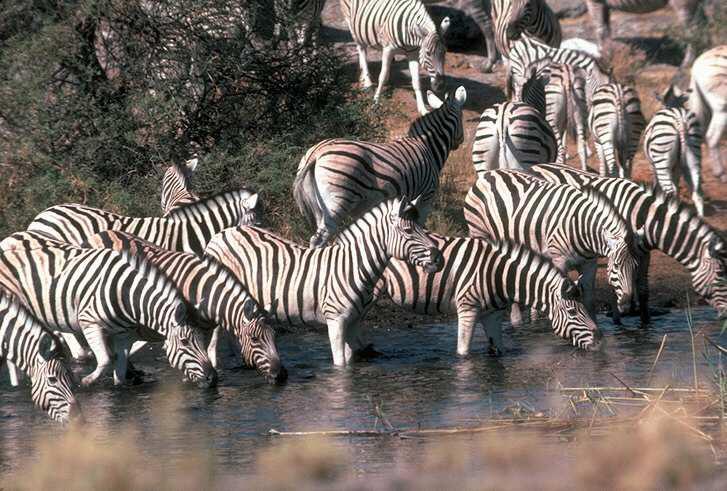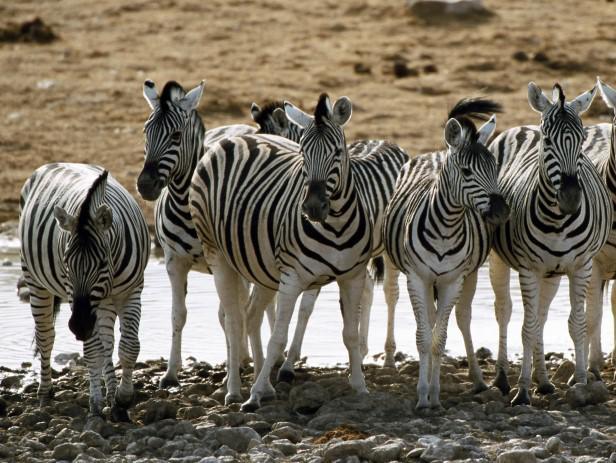The first image is the image on the left, the second image is the image on the right. Analyze the images presented: Is the assertion "In one of the images, some of the zebras are in the water, and in the other image, none of the zebras are in the water." valid? Answer yes or no. Yes. The first image is the image on the left, the second image is the image on the right. Examine the images to the left and right. Is the description "In the right image, there are zebras drinking from water." accurate? Answer yes or no. No. 